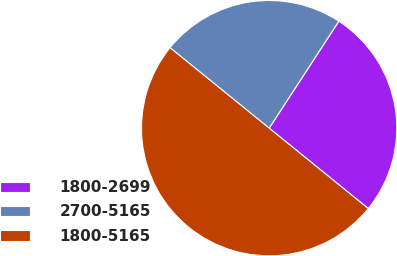Convert chart to OTSL. <chart><loc_0><loc_0><loc_500><loc_500><pie_chart><fcel>1800-2699<fcel>2700-5165<fcel>1800-5165<nl><fcel>26.66%<fcel>23.34%<fcel>50.0%<nl></chart> 